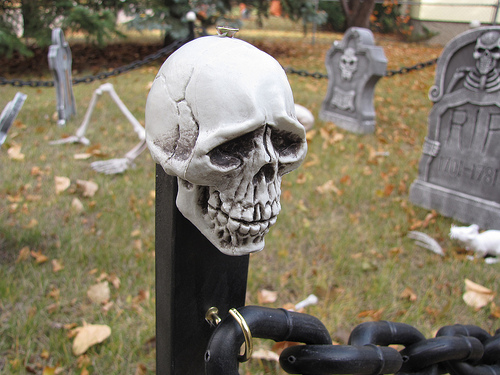<image>
Is the skull above the chain? Yes. The skull is positioned above the chain in the vertical space, higher up in the scene. Is there a headstone behind the skull? Yes. From this viewpoint, the headstone is positioned behind the skull, with the skull partially or fully occluding the headstone. Is there a skull behind the chain? No. The skull is not behind the chain. From this viewpoint, the skull appears to be positioned elsewhere in the scene. Is there a skull behind the tombstone? No. The skull is not behind the tombstone. From this viewpoint, the skull appears to be positioned elsewhere in the scene. 